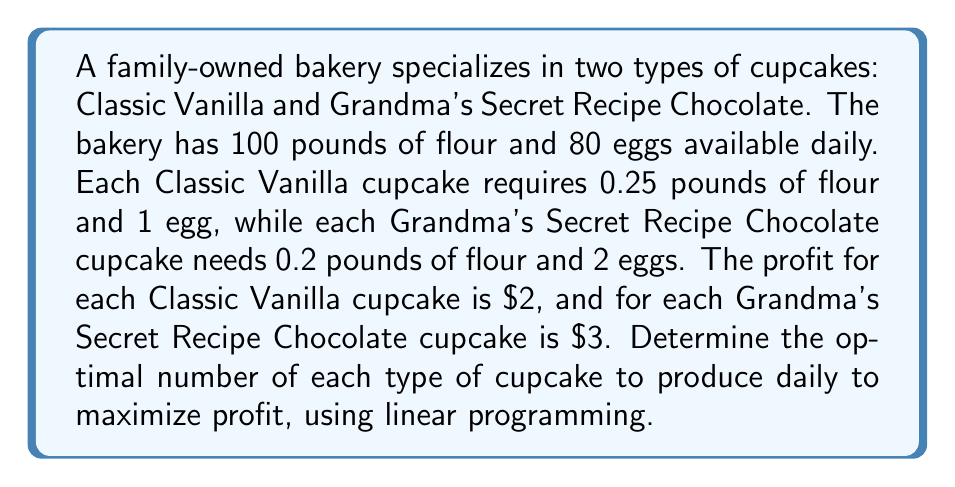Provide a solution to this math problem. Let's approach this step-by-step using linear programming:

1) Define variables:
   Let $x$ = number of Classic Vanilla cupcakes
   Let $y$ = number of Grandma's Secret Recipe Chocolate cupcakes

2) Objective function (to maximize profit):
   $$ \text{Maximize } Z = 2x + 3y $$

3) Constraints:
   Flour constraint: $0.25x + 0.2y \leq 100$
   Egg constraint: $x + 2y \leq 80$
   Non-negativity: $x \geq 0, y \geq 0$

4) Simplify constraints:
   Flour: $5x + 4y \leq 2000$
   Eggs: $x + 2y \leq 80$

5) Graph the constraints:
   [asy]
   import graph;
   size(200);
   xaxis("x", 0, 450);
   yaxis("y", 0, 150);
   draw((0,40)--(80,0), blue);
   draw((0,500)--(400,0), red);
   label("Eggs", (40,20), blue);
   label("Flour", (200,250), red);
   fill((0,0)--(0,40)--(80,0)--cycle, paleblue);
   [/asy]

6) Find intersection points:
   - Origin (0,0)
   - x-intercept of egg constraint (80,0)
   - Intersection of constraints:
     Solve $5x + 4y = 2000$ and $x + 2y = 80$
     $5(80-2y) + 4y = 2000$
     $400 - 10y + 4y = 2000$
     $-6y = 1600$
     $y = -266.67$ (not in feasible region)

7) Evaluate objective function at feasible corners:
   At (0,0): $Z = 0$
   At (80,0): $Z = 2(80) + 3(0) = 160$
   At (400,0): $Z = 2(400) + 3(0) = 800$

8) The maximum profit occurs at (400,0), meaning produce 400 Classic Vanilla cupcakes and 0 Grandma's Secret Recipe Chocolate cupcakes.
Answer: The optimal product mix is to produce 400 Classic Vanilla cupcakes and 0 Grandma's Secret Recipe Chocolate cupcakes daily, resulting in a maximum profit of $800. 